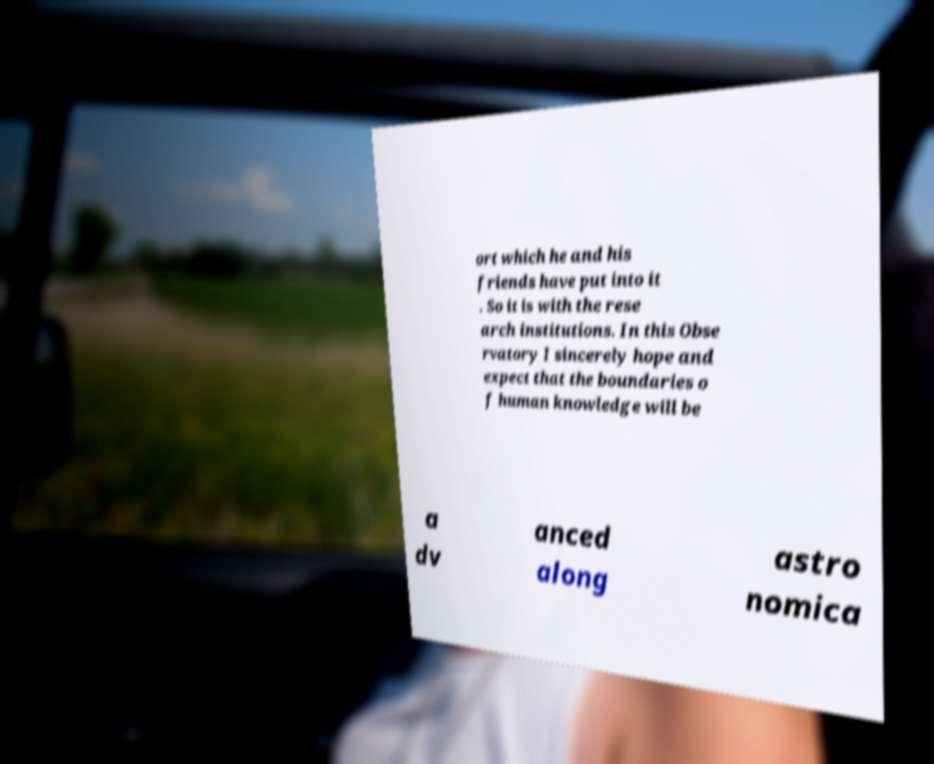Can you read and provide the text displayed in the image?This photo seems to have some interesting text. Can you extract and type it out for me? ort which he and his friends have put into it . So it is with the rese arch institutions. In this Obse rvatory I sincerely hope and expect that the boundaries o f human knowledge will be a dv anced along astro nomica 